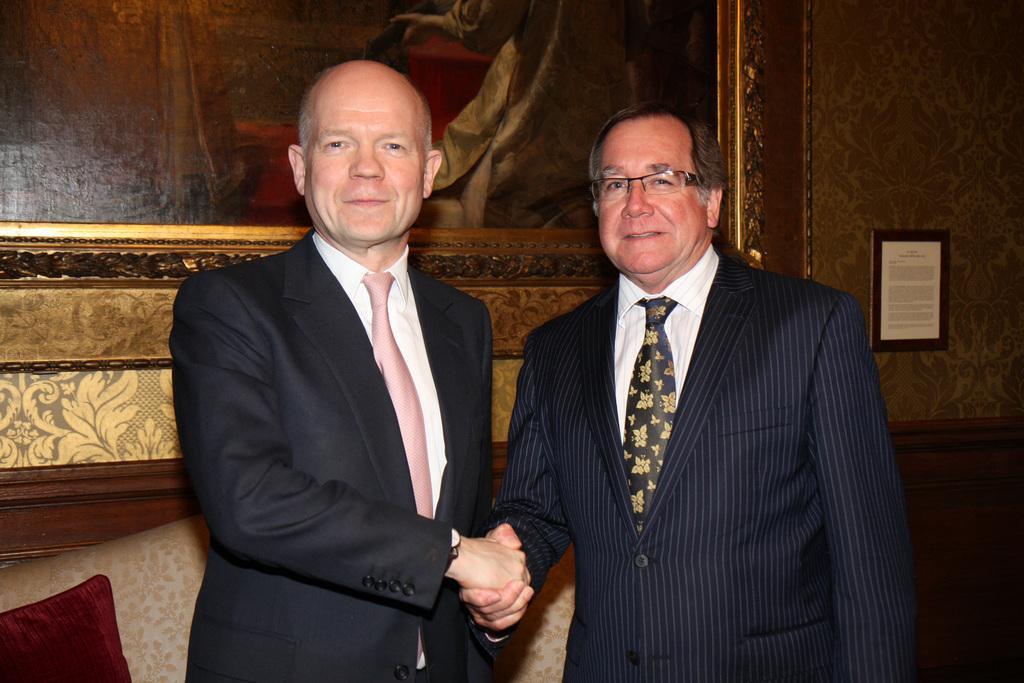In one or two sentences, can you explain what this image depicts? In this image we can see men standing and holding their hands. In the background there is a wall hanging attached to the wall and a couch. 